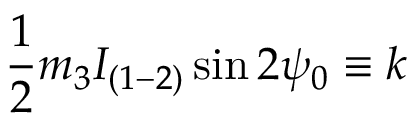<formula> <loc_0><loc_0><loc_500><loc_500>\frac { 1 } { 2 } m _ { 3 } I _ { ( 1 - 2 ) } \sin 2 \psi _ { 0 } \equiv k</formula> 